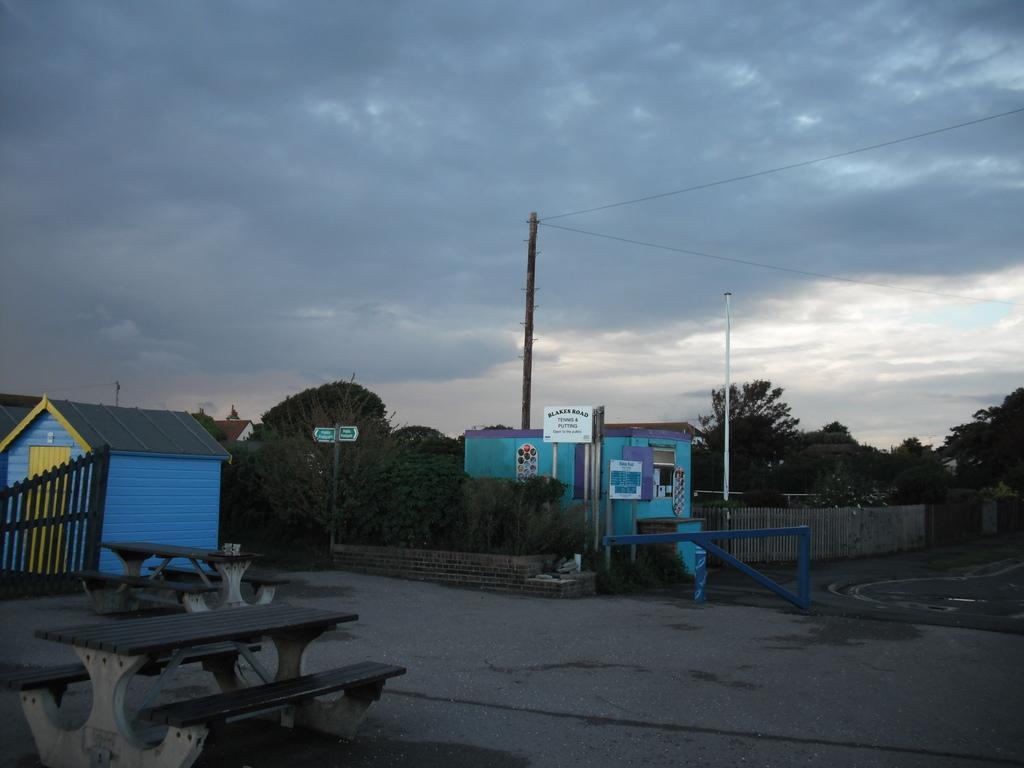In one or two sentences, can you explain what this image depicts? In this image I can see few benches on the ground, the fencing, few houses, few trees, a pole, 2 boards to the pole and in the background I can see the sky and few trees. 